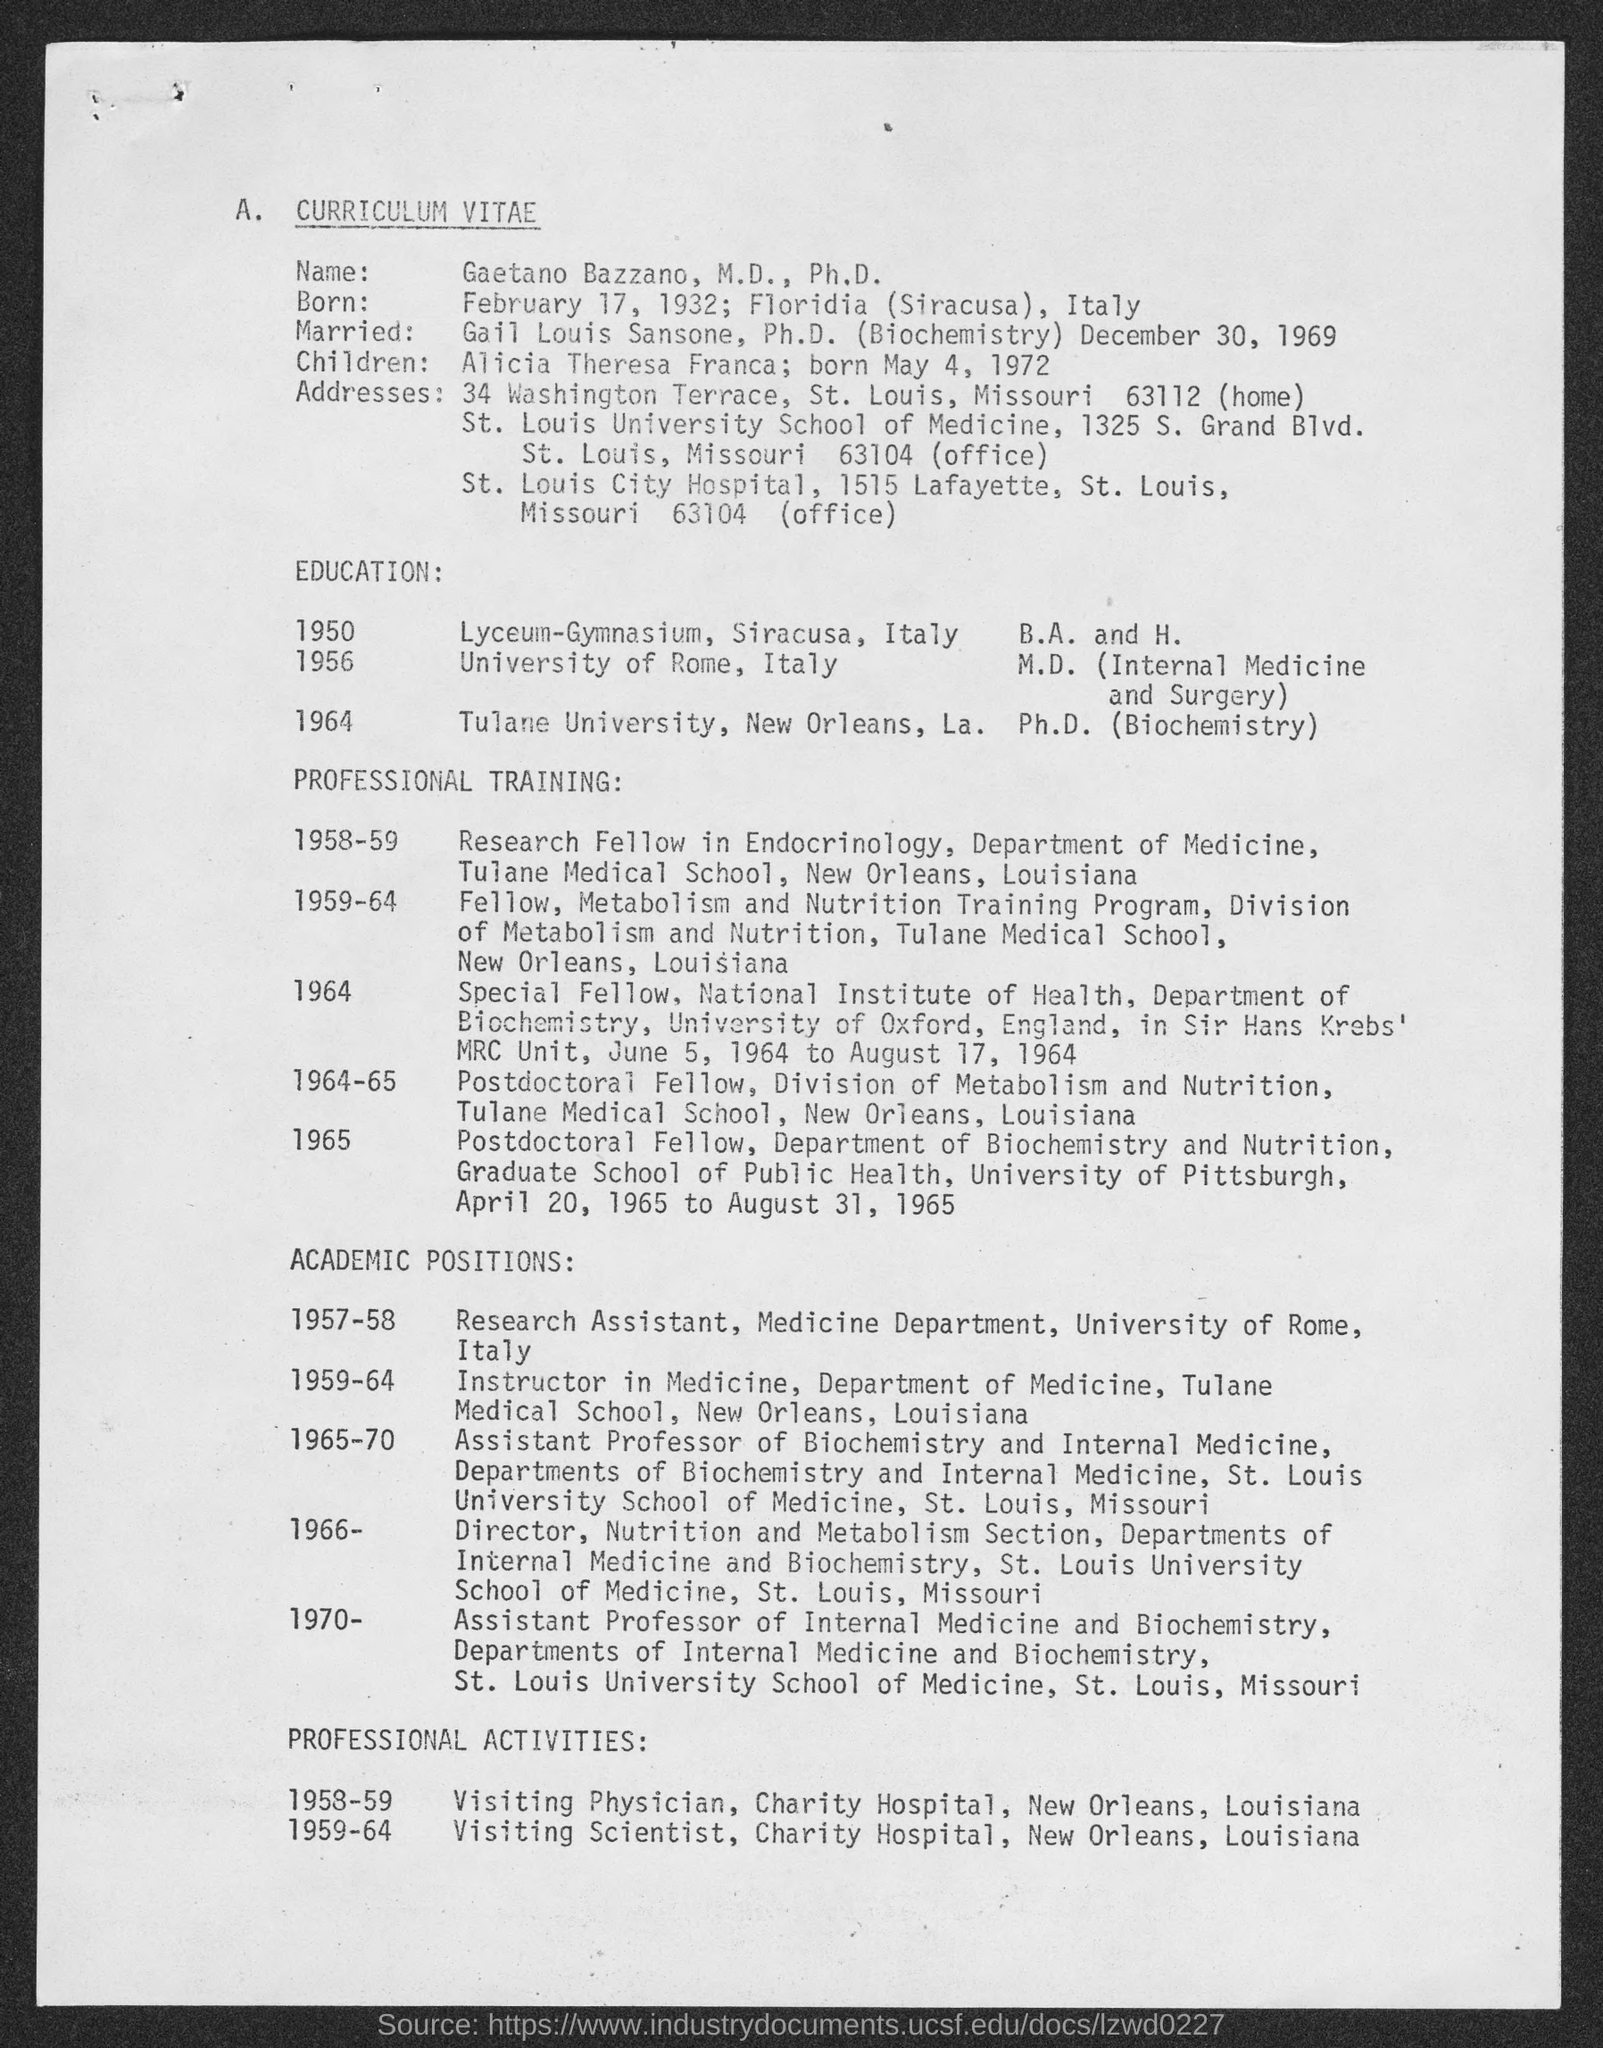What is the title of the Document?
Make the answer very short. A. Curriculum Vitae. 